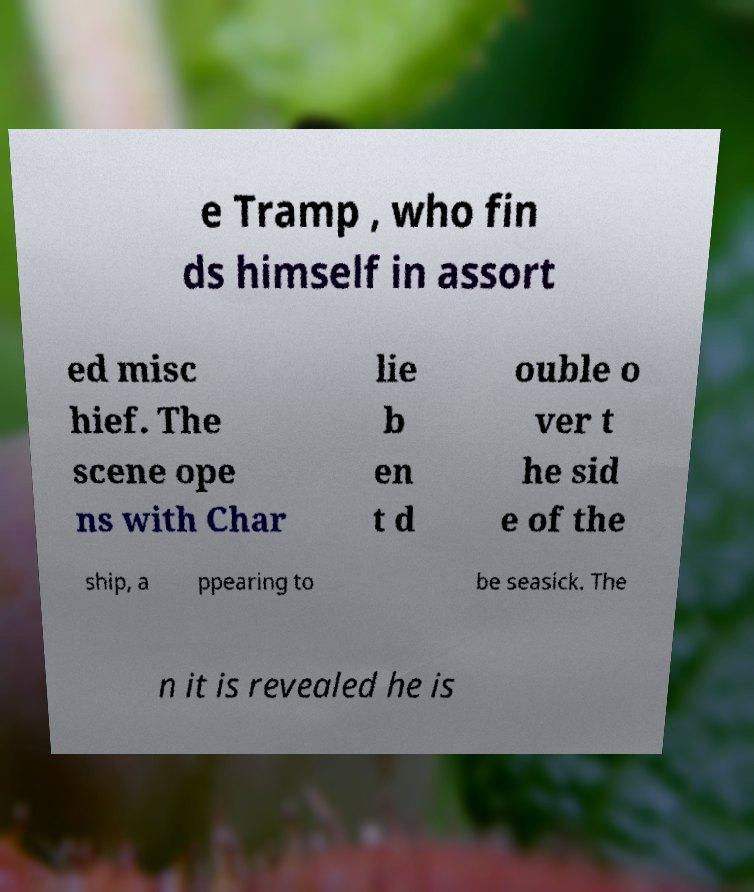There's text embedded in this image that I need extracted. Can you transcribe it verbatim? e Tramp , who fin ds himself in assort ed misc hief. The scene ope ns with Char lie b en t d ouble o ver t he sid e of the ship, a ppearing to be seasick. The n it is revealed he is 